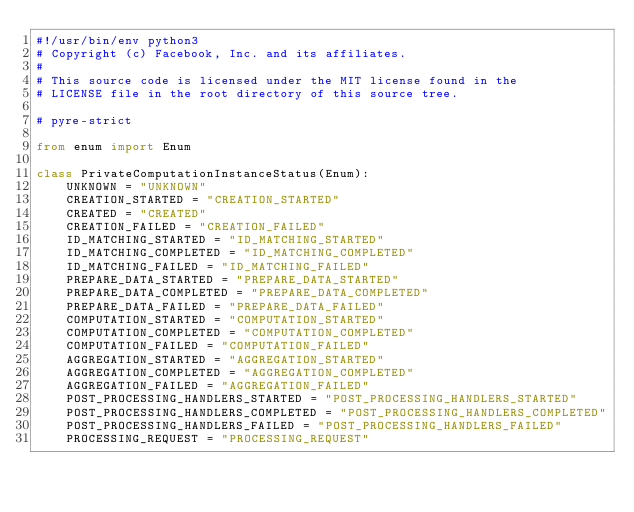<code> <loc_0><loc_0><loc_500><loc_500><_Python_>#!/usr/bin/env python3
# Copyright (c) Facebook, Inc. and its affiliates.
#
# This source code is licensed under the MIT license found in the
# LICENSE file in the root directory of this source tree.

# pyre-strict

from enum import Enum

class PrivateComputationInstanceStatus(Enum):
    UNKNOWN = "UNKNOWN"
    CREATION_STARTED = "CREATION_STARTED"
    CREATED = "CREATED"
    CREATION_FAILED = "CREATION_FAILED"
    ID_MATCHING_STARTED = "ID_MATCHING_STARTED"
    ID_MATCHING_COMPLETED = "ID_MATCHING_COMPLETED"
    ID_MATCHING_FAILED = "ID_MATCHING_FAILED"
    PREPARE_DATA_STARTED = "PREPARE_DATA_STARTED"
    PREPARE_DATA_COMPLETED = "PREPARE_DATA_COMPLETED"
    PREPARE_DATA_FAILED = "PREPARE_DATA_FAILED"
    COMPUTATION_STARTED = "COMPUTATION_STARTED"
    COMPUTATION_COMPLETED = "COMPUTATION_COMPLETED"
    COMPUTATION_FAILED = "COMPUTATION_FAILED"
    AGGREGATION_STARTED = "AGGREGATION_STARTED"
    AGGREGATION_COMPLETED = "AGGREGATION_COMPLETED"
    AGGREGATION_FAILED = "AGGREGATION_FAILED"
    POST_PROCESSING_HANDLERS_STARTED = "POST_PROCESSING_HANDLERS_STARTED"
    POST_PROCESSING_HANDLERS_COMPLETED = "POST_PROCESSING_HANDLERS_COMPLETED"
    POST_PROCESSING_HANDLERS_FAILED = "POST_PROCESSING_HANDLERS_FAILED"
    PROCESSING_REQUEST = "PROCESSING_REQUEST"
</code> 